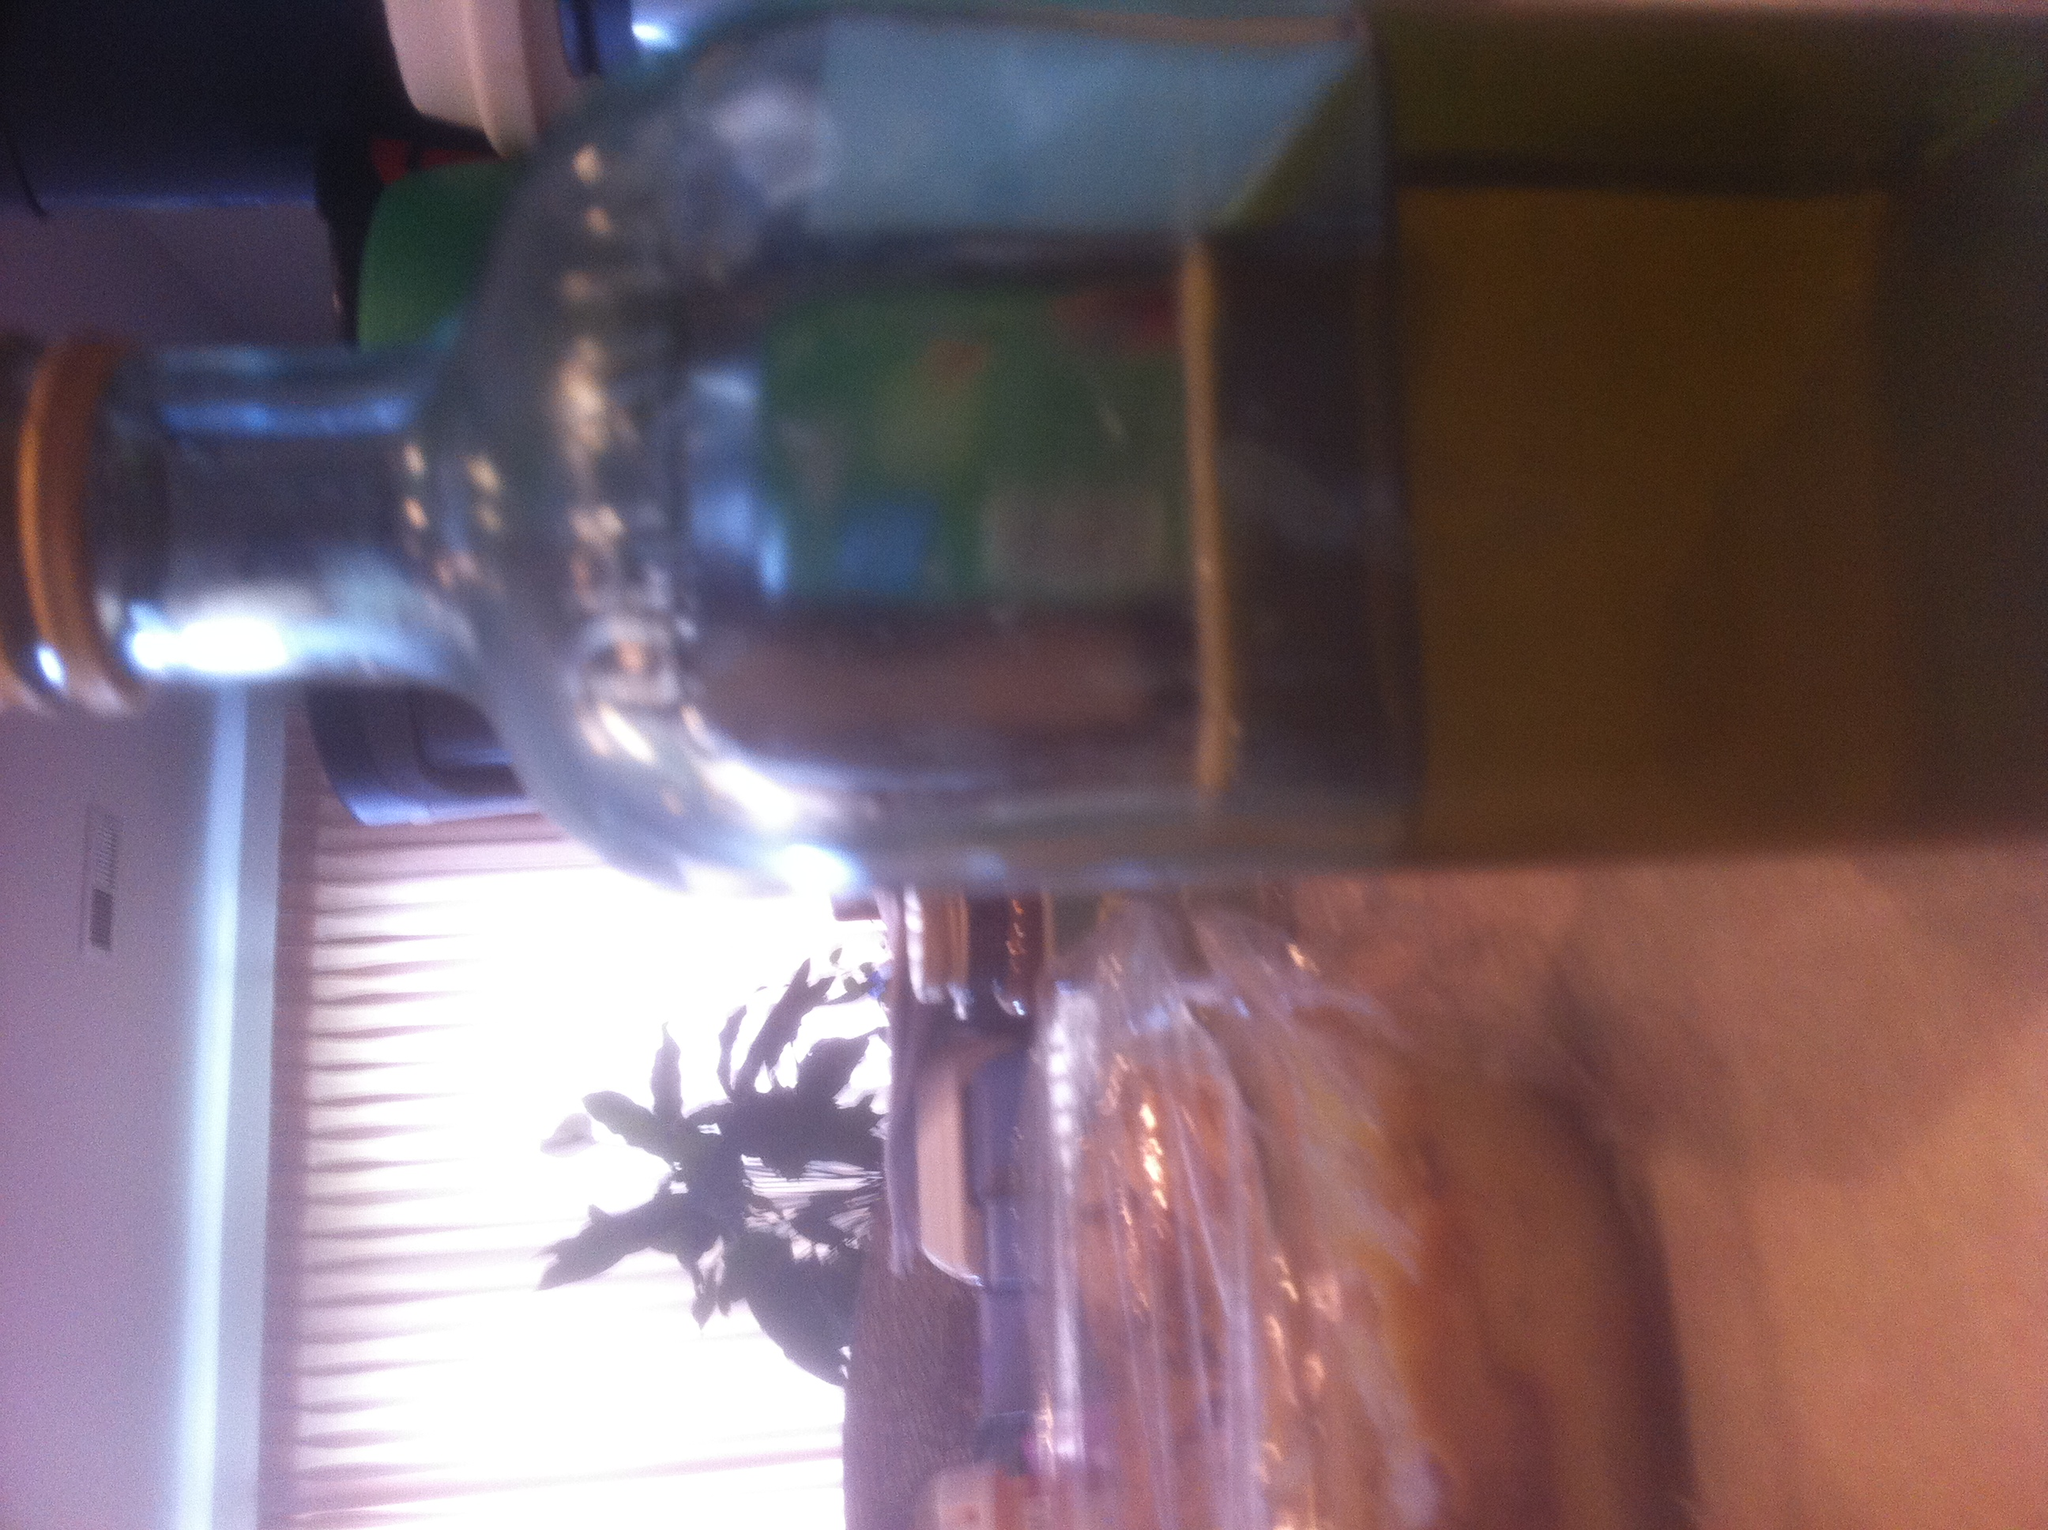If this bottle had a magical ability, what would it be and why? Imagine if this bottle had the magical ability to instantly age whatever liquid it contained, transforming fresh grape juice into fine vintage wine in mere moments. This magical ability could revolutionize the culinary world, allowing chefs and culinary enthusiasts to create rich, flavorful dishes with aged ingredients on the spot. It would be a coveted item, blending the line between ancient alchemical practices and modern culinary arts. 